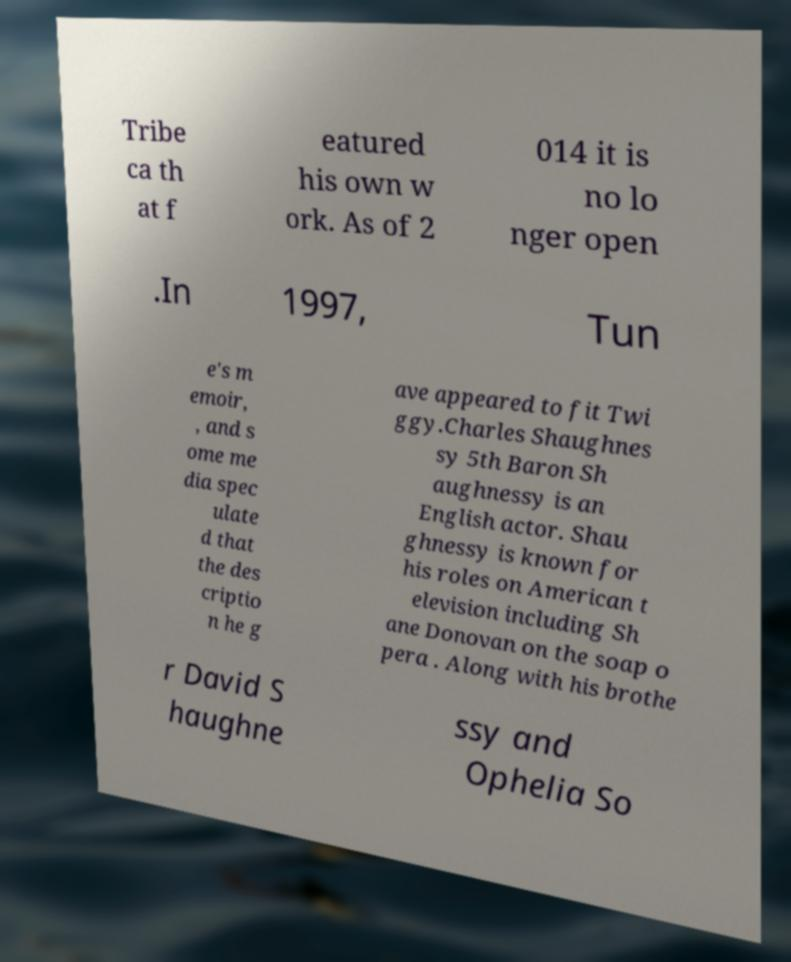Could you extract and type out the text from this image? Tribe ca th at f eatured his own w ork. As of 2 014 it is no lo nger open .In 1997, Tun e's m emoir, , and s ome me dia spec ulate d that the des criptio n he g ave appeared to fit Twi ggy.Charles Shaughnes sy 5th Baron Sh aughnessy is an English actor. Shau ghnessy is known for his roles on American t elevision including Sh ane Donovan on the soap o pera . Along with his brothe r David S haughne ssy and Ophelia So 